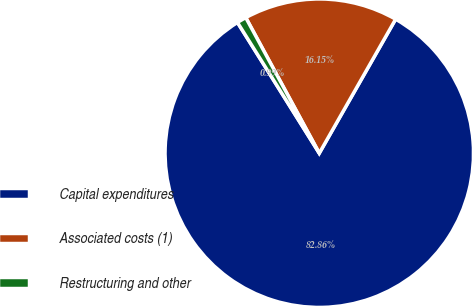<chart> <loc_0><loc_0><loc_500><loc_500><pie_chart><fcel>Capital expenditures<fcel>Associated costs (1)<fcel>Restructuring and other<nl><fcel>82.86%<fcel>16.15%<fcel>0.99%<nl></chart> 